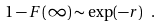<formula> <loc_0><loc_0><loc_500><loc_500>1 - F ( \infty ) \sim \exp ( - r ) \ .</formula> 